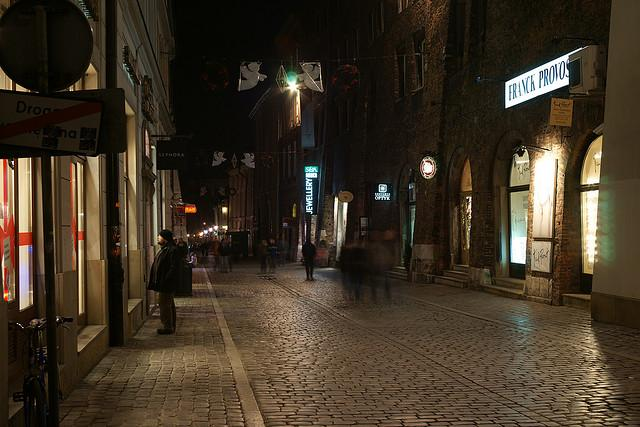What zone is depicted in the photo? pedestrian 